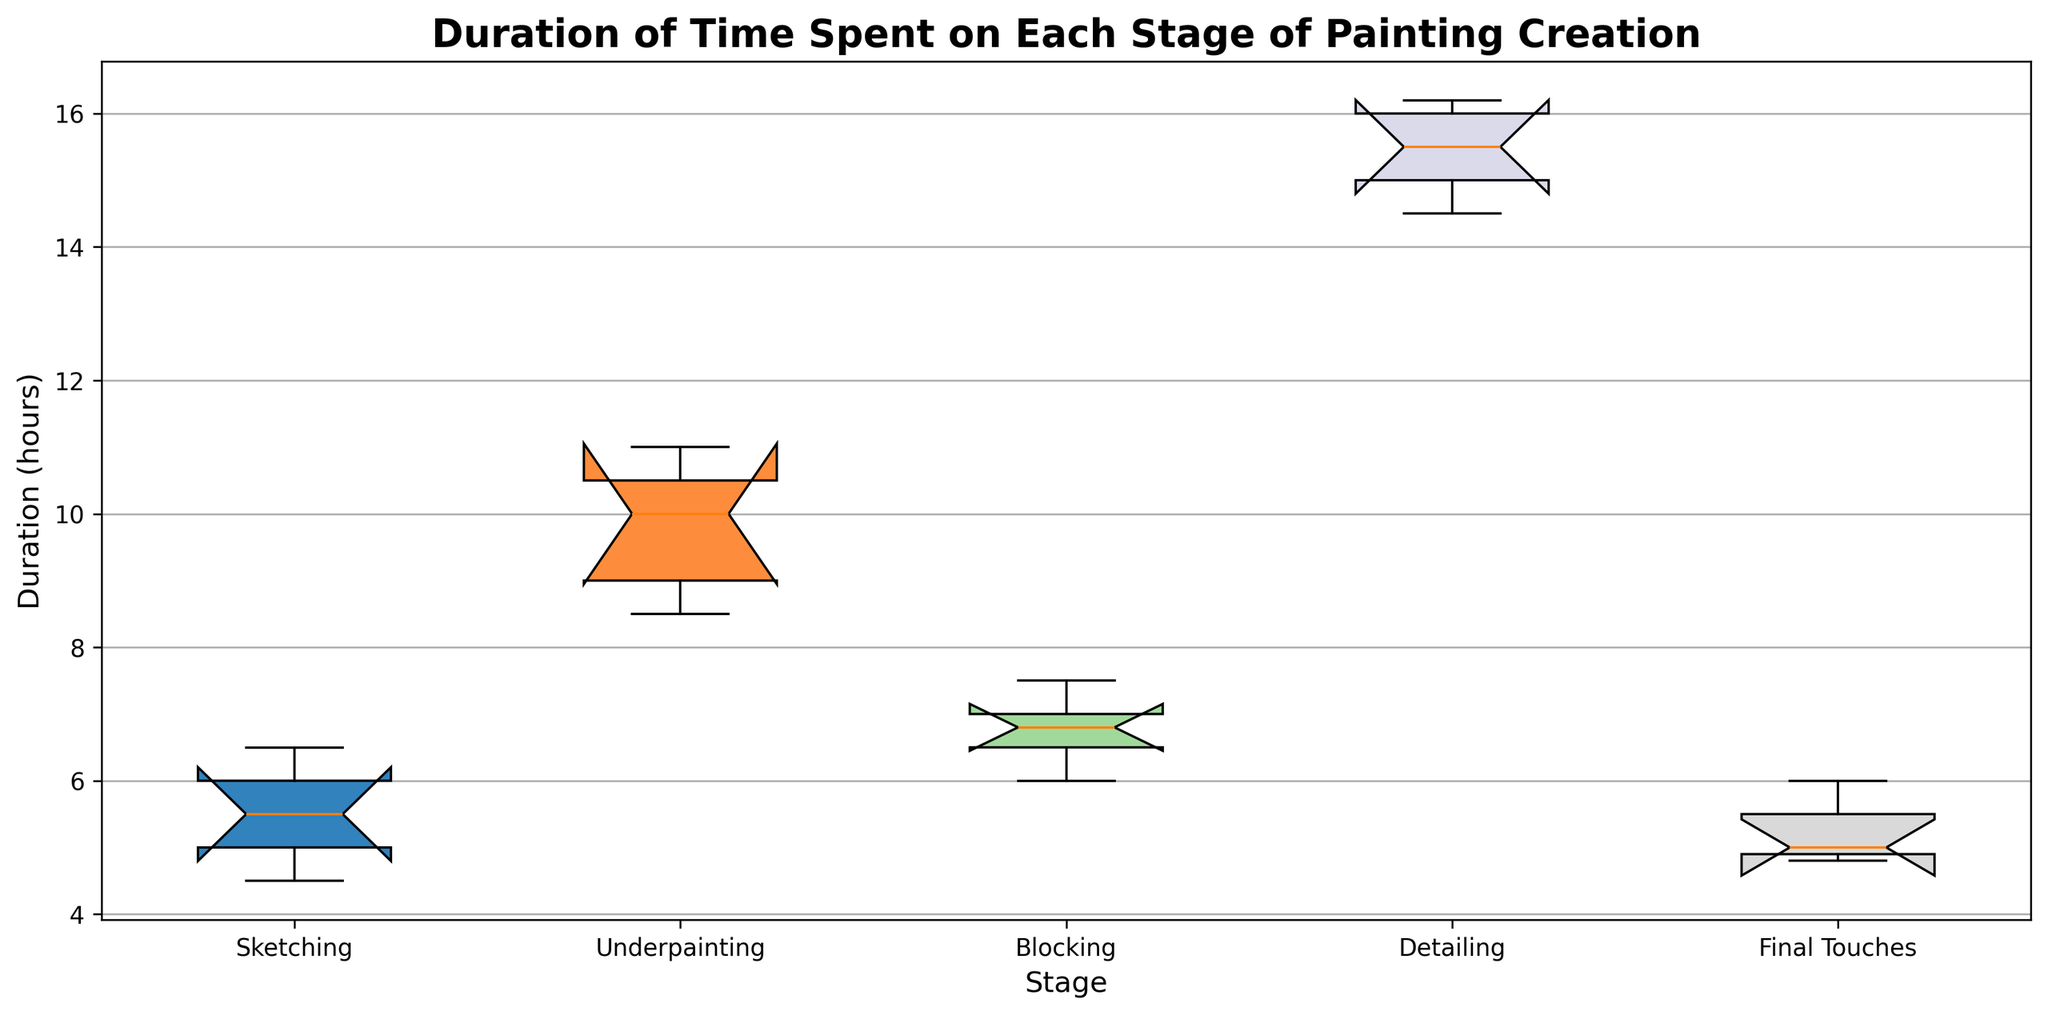What stage has the highest median duration? Looking at the chart, the median is indicated by the line inside the box. The median line for "Detailing" is visually higher than the others.
Answer: Detailing Which stage has the lowest median duration? The median line inside the box for "Final Touches" is lower than all the other stages.
Answer: Final Touches At which stage is the interquartile range (IQR) the smallest? The IQR is represented by the height of the box. By comparing the heights visually, "Final Touches" has the smallest box.
Answer: Final Touches What is the range of durations for Underpainting? The range is given by the difference between the maximum and minimum whiskers of "Underpainting". Visually, the whiskers range from 8.5 to 11.
Answer: 2.5 hours Which stage shows potential outliers? Potential outliers are typically shown as dots outside the whiskers, but in this chart, none of the stages have such dots.
Answer: None Compare the IQRs of Sketching and Blocking. Which is larger? The IQR is the height of the box. The box for "Blocking" is taller than the box for "Sketching".
Answer: Blocking How do the median durations of Sketching and Final Touches compare? The median line in "Sketching" is higher than the median line in "Final Touches".
Answer: Sketching is higher Which stages have overlapping IQRs? If the boxes overlap vertically, their IQRs have some common values. "Sketching" and "Final Touches" have overlapping boxes.
Answer: Sketching and Final Touches What's the approximate range of durations for Blocking? The range is the distance between the minimum and maximum whiskers. For "Blocking", it ranges from about 6 to 7.5.
Answer: 1.5 hours 